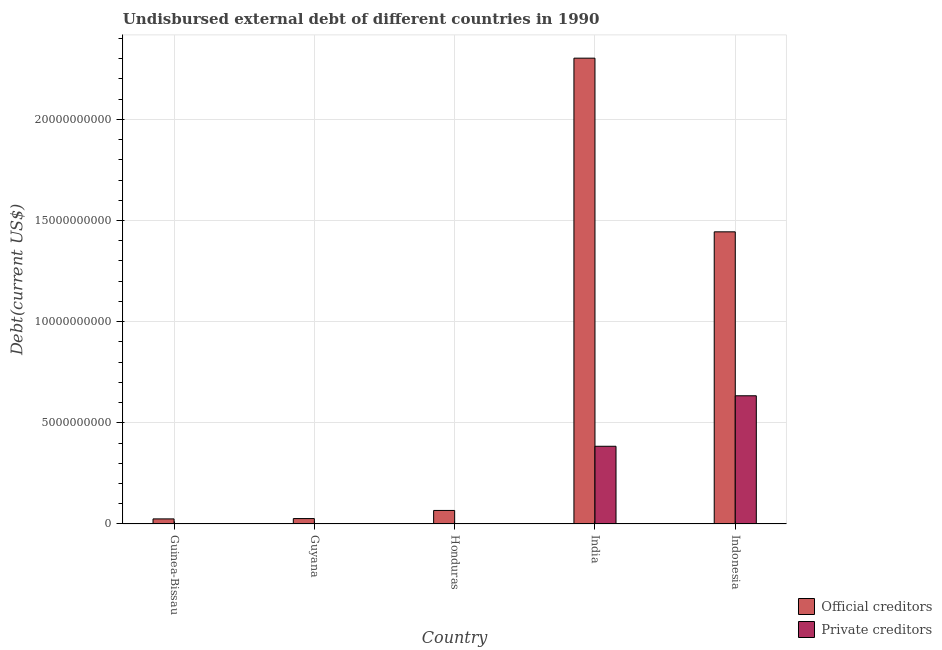How many different coloured bars are there?
Provide a short and direct response. 2. How many groups of bars are there?
Provide a short and direct response. 5. Are the number of bars on each tick of the X-axis equal?
Give a very brief answer. Yes. How many bars are there on the 1st tick from the left?
Provide a short and direct response. 2. What is the label of the 2nd group of bars from the left?
Give a very brief answer. Guyana. In how many cases, is the number of bars for a given country not equal to the number of legend labels?
Your answer should be compact. 0. What is the undisbursed external debt of private creditors in Honduras?
Give a very brief answer. 1.19e+07. Across all countries, what is the maximum undisbursed external debt of official creditors?
Keep it short and to the point. 2.30e+1. Across all countries, what is the minimum undisbursed external debt of official creditors?
Keep it short and to the point. 2.51e+08. In which country was the undisbursed external debt of official creditors maximum?
Make the answer very short. India. In which country was the undisbursed external debt of private creditors minimum?
Offer a terse response. Guyana. What is the total undisbursed external debt of official creditors in the graph?
Your answer should be very brief. 3.87e+1. What is the difference between the undisbursed external debt of private creditors in Guyana and that in Indonesia?
Your answer should be compact. -6.33e+09. What is the difference between the undisbursed external debt of official creditors in Guyana and the undisbursed external debt of private creditors in Guinea-Bissau?
Give a very brief answer. 2.59e+08. What is the average undisbursed external debt of private creditors per country?
Offer a terse response. 2.04e+09. What is the difference between the undisbursed external debt of official creditors and undisbursed external debt of private creditors in Guyana?
Ensure brevity in your answer.  2.63e+08. What is the ratio of the undisbursed external debt of official creditors in Guyana to that in India?
Give a very brief answer. 0.01. Is the undisbursed external debt of official creditors in Honduras less than that in India?
Offer a terse response. Yes. Is the difference between the undisbursed external debt of official creditors in Guinea-Bissau and Guyana greater than the difference between the undisbursed external debt of private creditors in Guinea-Bissau and Guyana?
Offer a very short reply. No. What is the difference between the highest and the second highest undisbursed external debt of private creditors?
Offer a very short reply. 2.50e+09. What is the difference between the highest and the lowest undisbursed external debt of official creditors?
Your answer should be compact. 2.28e+1. What does the 1st bar from the left in Guinea-Bissau represents?
Provide a short and direct response. Official creditors. What does the 2nd bar from the right in Indonesia represents?
Your answer should be very brief. Official creditors. How many bars are there?
Ensure brevity in your answer.  10. What is the difference between two consecutive major ticks on the Y-axis?
Keep it short and to the point. 5.00e+09. Does the graph contain grids?
Offer a terse response. Yes. Where does the legend appear in the graph?
Provide a short and direct response. Bottom right. How are the legend labels stacked?
Provide a short and direct response. Vertical. What is the title of the graph?
Give a very brief answer. Undisbursed external debt of different countries in 1990. Does "Transport services" appear as one of the legend labels in the graph?
Your response must be concise. No. What is the label or title of the Y-axis?
Your answer should be very brief. Debt(current US$). What is the Debt(current US$) of Official creditors in Guinea-Bissau?
Your answer should be very brief. 2.51e+08. What is the Debt(current US$) in Private creditors in Guinea-Bissau?
Provide a succinct answer. 8.34e+06. What is the Debt(current US$) of Official creditors in Guyana?
Ensure brevity in your answer.  2.67e+08. What is the Debt(current US$) of Private creditors in Guyana?
Give a very brief answer. 4.30e+06. What is the Debt(current US$) of Official creditors in Honduras?
Keep it short and to the point. 6.69e+08. What is the Debt(current US$) in Private creditors in Honduras?
Your response must be concise. 1.19e+07. What is the Debt(current US$) of Official creditors in India?
Ensure brevity in your answer.  2.30e+1. What is the Debt(current US$) in Private creditors in India?
Offer a very short reply. 3.84e+09. What is the Debt(current US$) in Official creditors in Indonesia?
Your answer should be compact. 1.44e+1. What is the Debt(current US$) of Private creditors in Indonesia?
Ensure brevity in your answer.  6.34e+09. Across all countries, what is the maximum Debt(current US$) in Official creditors?
Ensure brevity in your answer.  2.30e+1. Across all countries, what is the maximum Debt(current US$) of Private creditors?
Make the answer very short. 6.34e+09. Across all countries, what is the minimum Debt(current US$) of Official creditors?
Offer a very short reply. 2.51e+08. Across all countries, what is the minimum Debt(current US$) of Private creditors?
Your response must be concise. 4.30e+06. What is the total Debt(current US$) in Official creditors in the graph?
Ensure brevity in your answer.  3.87e+1. What is the total Debt(current US$) in Private creditors in the graph?
Your response must be concise. 1.02e+1. What is the difference between the Debt(current US$) in Official creditors in Guinea-Bissau and that in Guyana?
Give a very brief answer. -1.66e+07. What is the difference between the Debt(current US$) of Private creditors in Guinea-Bissau and that in Guyana?
Offer a very short reply. 4.04e+06. What is the difference between the Debt(current US$) of Official creditors in Guinea-Bissau and that in Honduras?
Offer a very short reply. -4.18e+08. What is the difference between the Debt(current US$) of Private creditors in Guinea-Bissau and that in Honduras?
Give a very brief answer. -3.54e+06. What is the difference between the Debt(current US$) of Official creditors in Guinea-Bissau and that in India?
Ensure brevity in your answer.  -2.28e+1. What is the difference between the Debt(current US$) of Private creditors in Guinea-Bissau and that in India?
Offer a terse response. -3.83e+09. What is the difference between the Debt(current US$) of Official creditors in Guinea-Bissau and that in Indonesia?
Your answer should be compact. -1.42e+1. What is the difference between the Debt(current US$) in Private creditors in Guinea-Bissau and that in Indonesia?
Your answer should be compact. -6.33e+09. What is the difference between the Debt(current US$) in Official creditors in Guyana and that in Honduras?
Your response must be concise. -4.02e+08. What is the difference between the Debt(current US$) of Private creditors in Guyana and that in Honduras?
Ensure brevity in your answer.  -7.58e+06. What is the difference between the Debt(current US$) in Official creditors in Guyana and that in India?
Provide a succinct answer. -2.28e+1. What is the difference between the Debt(current US$) of Private creditors in Guyana and that in India?
Give a very brief answer. -3.84e+09. What is the difference between the Debt(current US$) of Official creditors in Guyana and that in Indonesia?
Your response must be concise. -1.42e+1. What is the difference between the Debt(current US$) in Private creditors in Guyana and that in Indonesia?
Provide a short and direct response. -6.33e+09. What is the difference between the Debt(current US$) in Official creditors in Honduras and that in India?
Give a very brief answer. -2.24e+1. What is the difference between the Debt(current US$) of Private creditors in Honduras and that in India?
Make the answer very short. -3.83e+09. What is the difference between the Debt(current US$) in Official creditors in Honduras and that in Indonesia?
Your answer should be compact. -1.38e+1. What is the difference between the Debt(current US$) in Private creditors in Honduras and that in Indonesia?
Provide a succinct answer. -6.32e+09. What is the difference between the Debt(current US$) of Official creditors in India and that in Indonesia?
Ensure brevity in your answer.  8.58e+09. What is the difference between the Debt(current US$) of Private creditors in India and that in Indonesia?
Your answer should be very brief. -2.50e+09. What is the difference between the Debt(current US$) in Official creditors in Guinea-Bissau and the Debt(current US$) in Private creditors in Guyana?
Offer a very short reply. 2.47e+08. What is the difference between the Debt(current US$) of Official creditors in Guinea-Bissau and the Debt(current US$) of Private creditors in Honduras?
Ensure brevity in your answer.  2.39e+08. What is the difference between the Debt(current US$) in Official creditors in Guinea-Bissau and the Debt(current US$) in Private creditors in India?
Keep it short and to the point. -3.59e+09. What is the difference between the Debt(current US$) of Official creditors in Guinea-Bissau and the Debt(current US$) of Private creditors in Indonesia?
Make the answer very short. -6.09e+09. What is the difference between the Debt(current US$) in Official creditors in Guyana and the Debt(current US$) in Private creditors in Honduras?
Provide a short and direct response. 2.56e+08. What is the difference between the Debt(current US$) in Official creditors in Guyana and the Debt(current US$) in Private creditors in India?
Provide a short and direct response. -3.57e+09. What is the difference between the Debt(current US$) in Official creditors in Guyana and the Debt(current US$) in Private creditors in Indonesia?
Offer a very short reply. -6.07e+09. What is the difference between the Debt(current US$) in Official creditors in Honduras and the Debt(current US$) in Private creditors in India?
Your answer should be compact. -3.17e+09. What is the difference between the Debt(current US$) of Official creditors in Honduras and the Debt(current US$) of Private creditors in Indonesia?
Your answer should be compact. -5.67e+09. What is the difference between the Debt(current US$) of Official creditors in India and the Debt(current US$) of Private creditors in Indonesia?
Offer a terse response. 1.67e+1. What is the average Debt(current US$) of Official creditors per country?
Make the answer very short. 7.73e+09. What is the average Debt(current US$) of Private creditors per country?
Keep it short and to the point. 2.04e+09. What is the difference between the Debt(current US$) of Official creditors and Debt(current US$) of Private creditors in Guinea-Bissau?
Keep it short and to the point. 2.43e+08. What is the difference between the Debt(current US$) in Official creditors and Debt(current US$) in Private creditors in Guyana?
Your answer should be compact. 2.63e+08. What is the difference between the Debt(current US$) of Official creditors and Debt(current US$) of Private creditors in Honduras?
Give a very brief answer. 6.57e+08. What is the difference between the Debt(current US$) of Official creditors and Debt(current US$) of Private creditors in India?
Your response must be concise. 1.92e+1. What is the difference between the Debt(current US$) in Official creditors and Debt(current US$) in Private creditors in Indonesia?
Your response must be concise. 8.10e+09. What is the ratio of the Debt(current US$) in Official creditors in Guinea-Bissau to that in Guyana?
Offer a very short reply. 0.94. What is the ratio of the Debt(current US$) in Private creditors in Guinea-Bissau to that in Guyana?
Give a very brief answer. 1.94. What is the ratio of the Debt(current US$) in Official creditors in Guinea-Bissau to that in Honduras?
Provide a succinct answer. 0.37. What is the ratio of the Debt(current US$) in Private creditors in Guinea-Bissau to that in Honduras?
Your answer should be very brief. 0.7. What is the ratio of the Debt(current US$) of Official creditors in Guinea-Bissau to that in India?
Ensure brevity in your answer.  0.01. What is the ratio of the Debt(current US$) in Private creditors in Guinea-Bissau to that in India?
Make the answer very short. 0. What is the ratio of the Debt(current US$) of Official creditors in Guinea-Bissau to that in Indonesia?
Your answer should be compact. 0.02. What is the ratio of the Debt(current US$) in Private creditors in Guinea-Bissau to that in Indonesia?
Ensure brevity in your answer.  0. What is the ratio of the Debt(current US$) in Official creditors in Guyana to that in Honduras?
Keep it short and to the point. 0.4. What is the ratio of the Debt(current US$) of Private creditors in Guyana to that in Honduras?
Provide a short and direct response. 0.36. What is the ratio of the Debt(current US$) in Official creditors in Guyana to that in India?
Give a very brief answer. 0.01. What is the ratio of the Debt(current US$) of Private creditors in Guyana to that in India?
Provide a succinct answer. 0. What is the ratio of the Debt(current US$) of Official creditors in Guyana to that in Indonesia?
Make the answer very short. 0.02. What is the ratio of the Debt(current US$) of Private creditors in Guyana to that in Indonesia?
Make the answer very short. 0. What is the ratio of the Debt(current US$) of Official creditors in Honduras to that in India?
Offer a terse response. 0.03. What is the ratio of the Debt(current US$) of Private creditors in Honduras to that in India?
Keep it short and to the point. 0. What is the ratio of the Debt(current US$) in Official creditors in Honduras to that in Indonesia?
Your answer should be very brief. 0.05. What is the ratio of the Debt(current US$) of Private creditors in Honduras to that in Indonesia?
Provide a short and direct response. 0. What is the ratio of the Debt(current US$) in Official creditors in India to that in Indonesia?
Ensure brevity in your answer.  1.59. What is the ratio of the Debt(current US$) in Private creditors in India to that in Indonesia?
Make the answer very short. 0.61. What is the difference between the highest and the second highest Debt(current US$) of Official creditors?
Make the answer very short. 8.58e+09. What is the difference between the highest and the second highest Debt(current US$) of Private creditors?
Make the answer very short. 2.50e+09. What is the difference between the highest and the lowest Debt(current US$) of Official creditors?
Offer a terse response. 2.28e+1. What is the difference between the highest and the lowest Debt(current US$) in Private creditors?
Offer a terse response. 6.33e+09. 